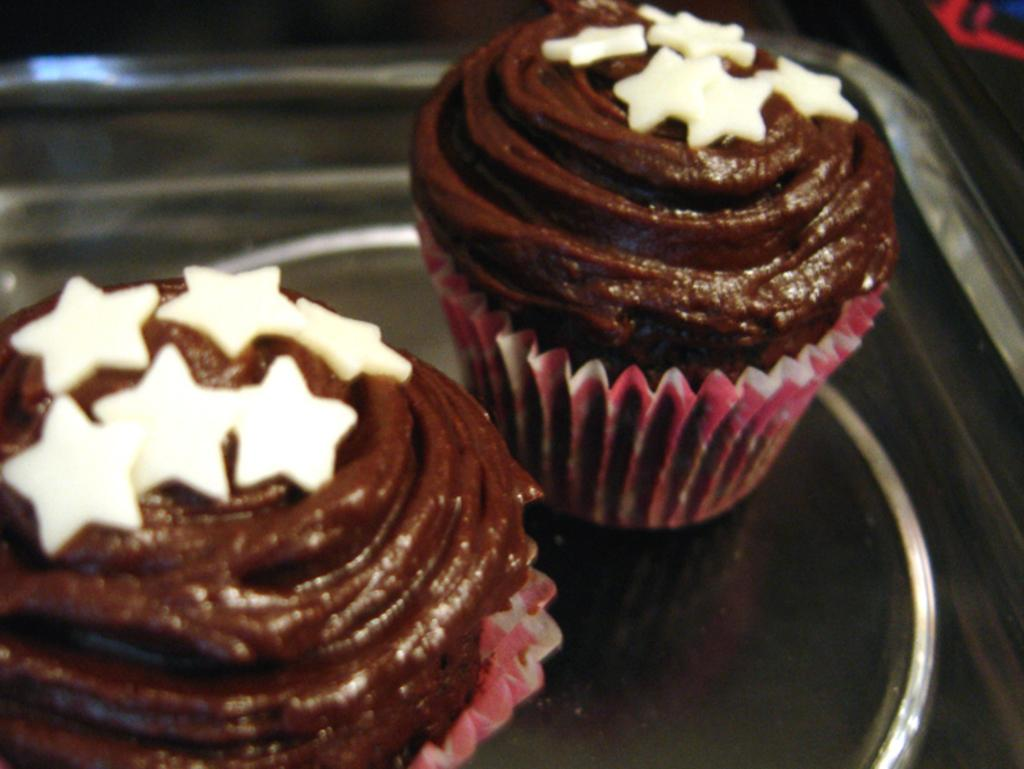How many cupcakes are visible in the image? There are two cupcakes in the image. Where are the cupcakes located? The cupcakes are placed on a tray. What is the color of the cream on the cupcakes? The cream on the cupcakes is brown-colored. What type of noise can be heard coming from the cupcakes in the image? There is no noise coming from the cupcakes in the image. Cupcakes do not make noise. 